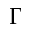Convert formula to latex. <formula><loc_0><loc_0><loc_500><loc_500>\Gamma</formula> 